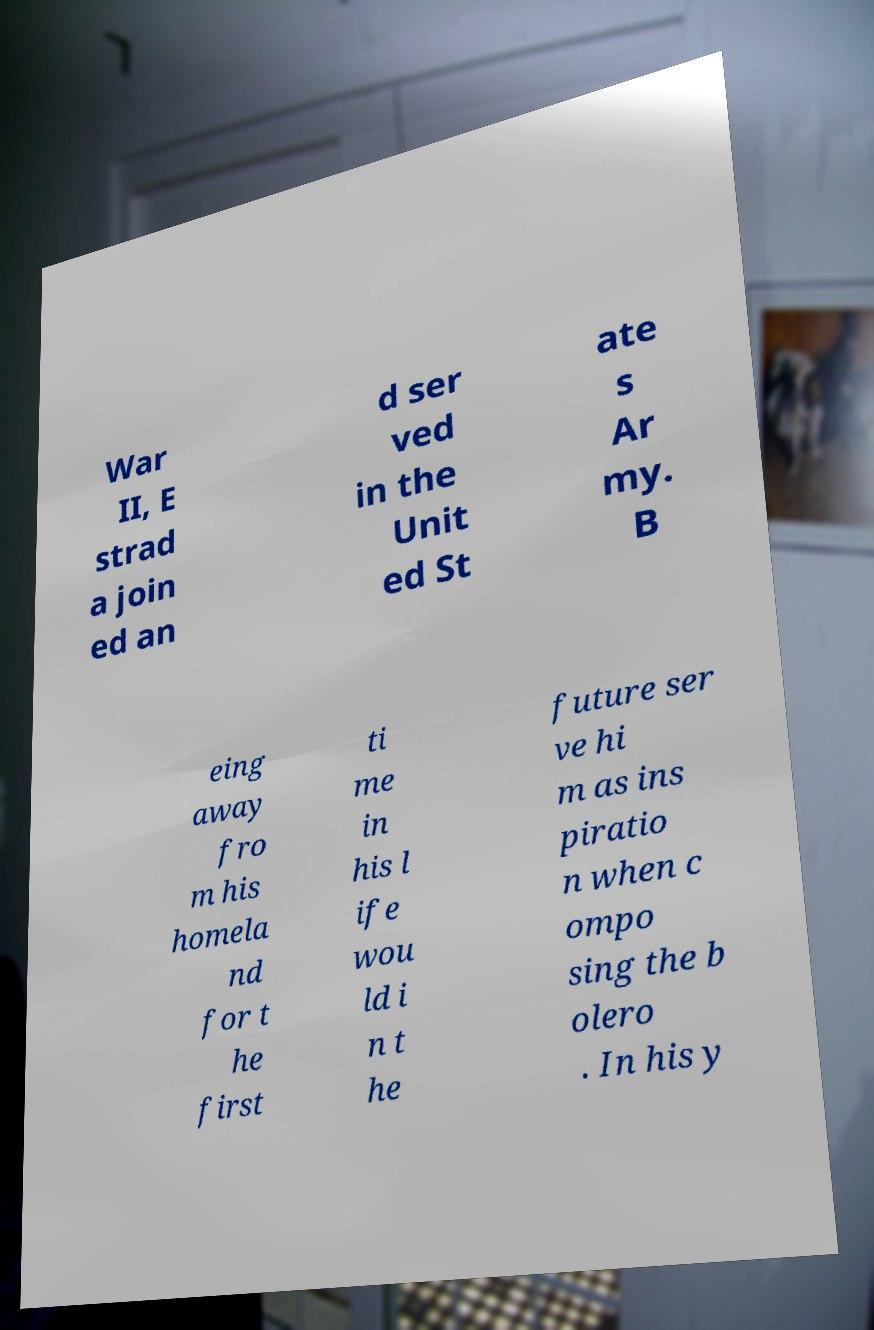Could you assist in decoding the text presented in this image and type it out clearly? War II, E strad a join ed an d ser ved in the Unit ed St ate s Ar my. B eing away fro m his homela nd for t he first ti me in his l ife wou ld i n t he future ser ve hi m as ins piratio n when c ompo sing the b olero . In his y 